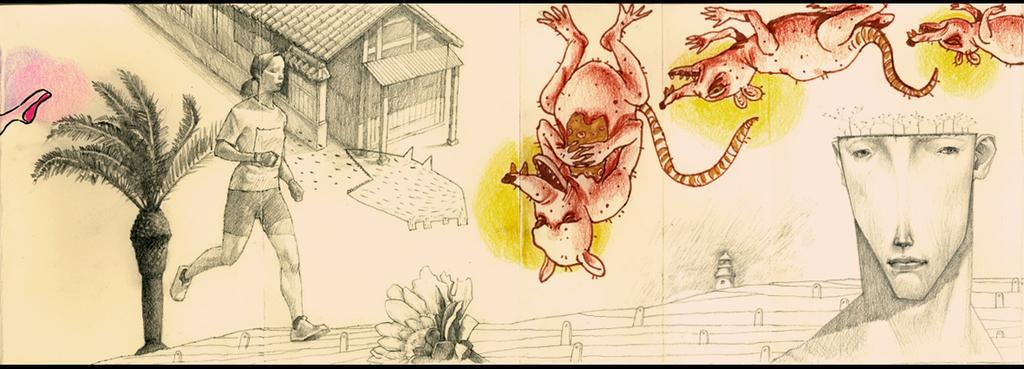How would you summarize this image in a sentence or two? In this image I can see the sketch of the house, windows, person, tree, flower and the person face. I can see few animals in different color. 